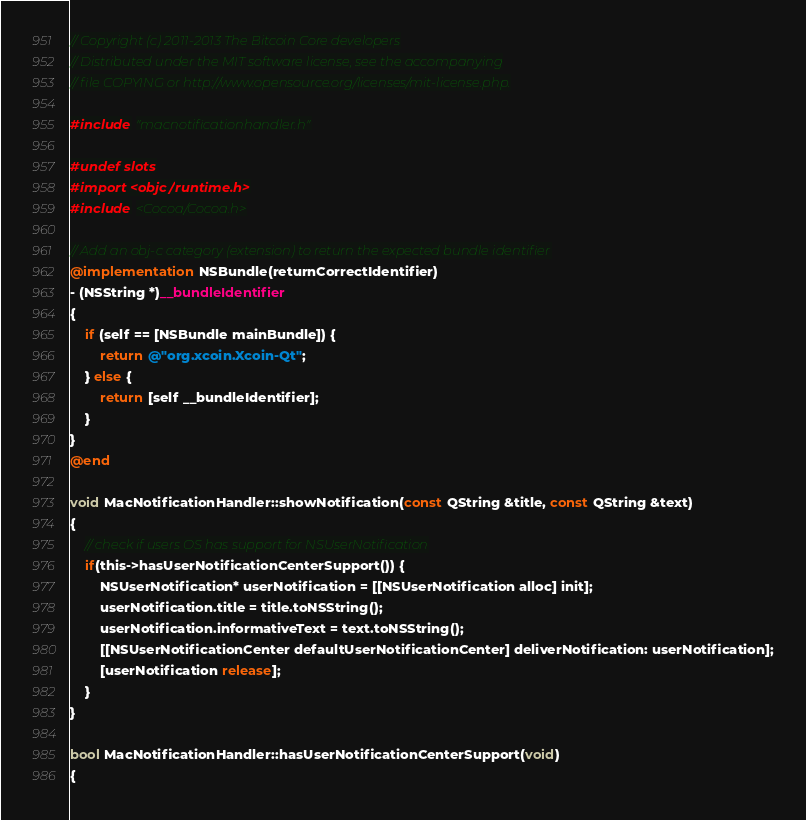Convert code to text. <code><loc_0><loc_0><loc_500><loc_500><_ObjectiveC_>// Copyright (c) 2011-2013 The Bitcoin Core developers
// Distributed under the MIT software license, see the accompanying
// file COPYING or http://www.opensource.org/licenses/mit-license.php.

#include "macnotificationhandler.h"

#undef slots
#import <objc/runtime.h>
#include <Cocoa/Cocoa.h>

// Add an obj-c category (extension) to return the expected bundle identifier
@implementation NSBundle(returnCorrectIdentifier)
- (NSString *)__bundleIdentifier
{
    if (self == [NSBundle mainBundle]) {
        return @"org.xcoin.Xcoin-Qt";
    } else {
        return [self __bundleIdentifier];
    }
}
@end

void MacNotificationHandler::showNotification(const QString &title, const QString &text)
{
    // check if users OS has support for NSUserNotification
    if(this->hasUserNotificationCenterSupport()) {
        NSUserNotification* userNotification = [[NSUserNotification alloc] init];
        userNotification.title = title.toNSString();
        userNotification.informativeText = text.toNSString();
        [[NSUserNotificationCenter defaultUserNotificationCenter] deliverNotification: userNotification];
        [userNotification release];
    }
}

bool MacNotificationHandler::hasUserNotificationCenterSupport(void)
{</code> 